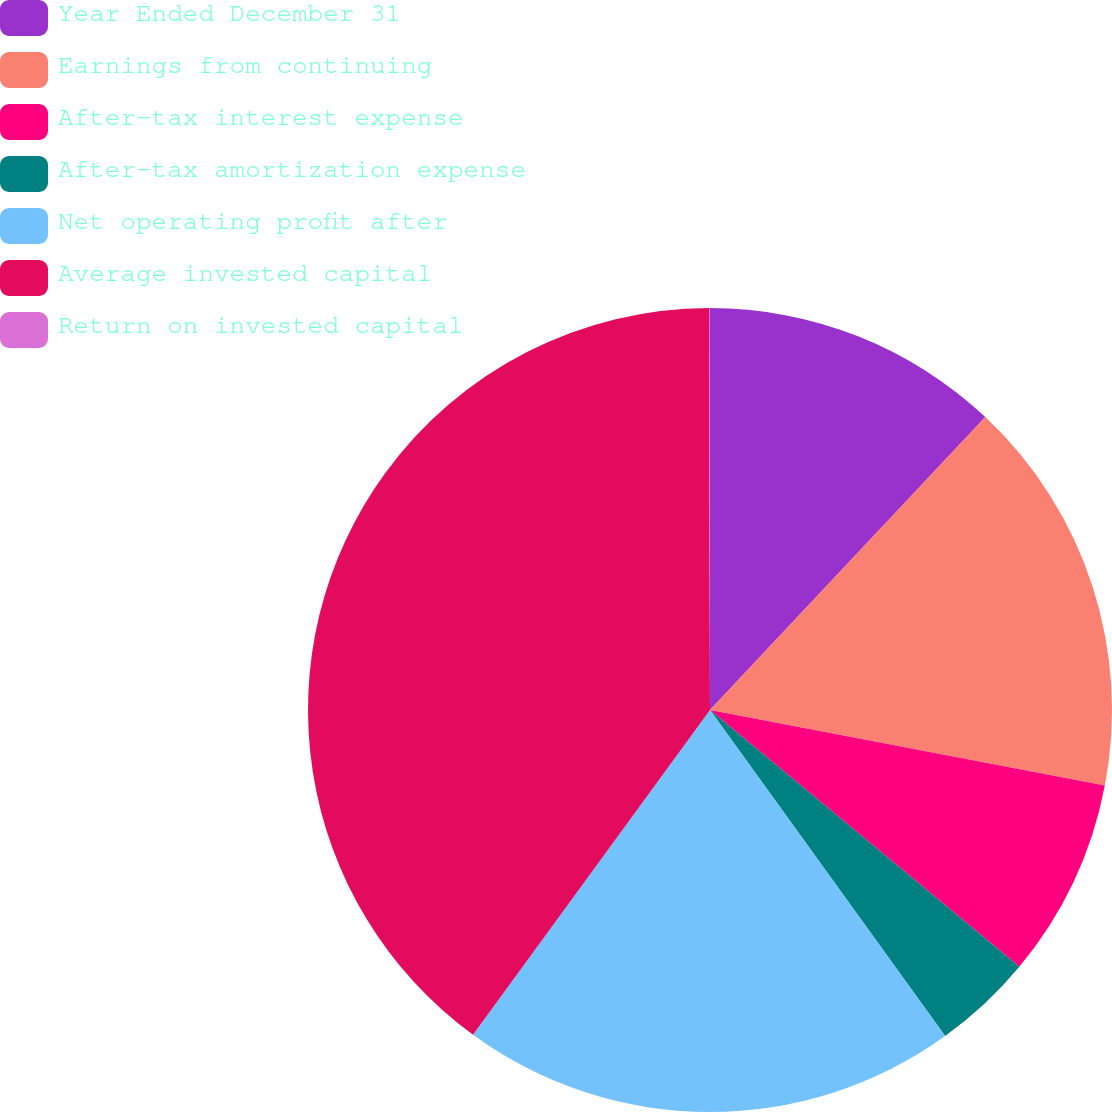Convert chart to OTSL. <chart><loc_0><loc_0><loc_500><loc_500><pie_chart><fcel>Year Ended December 31<fcel>Earnings from continuing<fcel>After-tax interest expense<fcel>After-tax amortization expense<fcel>Net operating profit after<fcel>Average invested capital<fcel>Return on invested capital<nl><fcel>12.01%<fcel>16.0%<fcel>8.02%<fcel>4.03%<fcel>19.98%<fcel>39.93%<fcel>0.04%<nl></chart> 